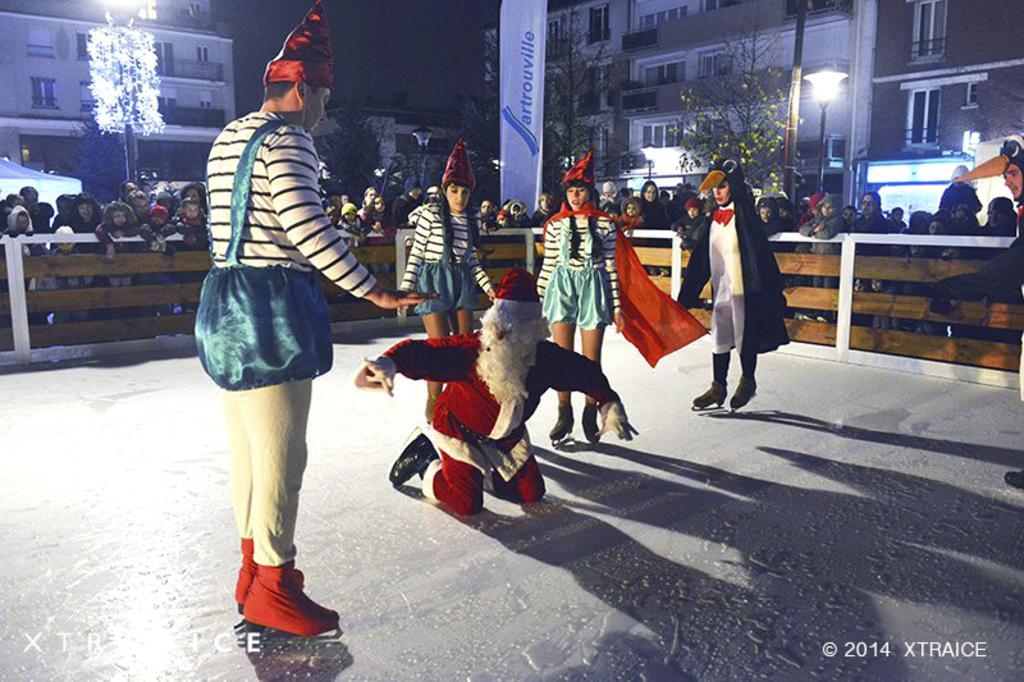Could you give a brief overview of what you see in this image? In this image I can see number of people. In the front I can see few people are wearing costumes. In the background I can see a white colour board, few trees, few lights, few buildings and on the board I can see something is written. On the bottom right side of the image I can see a watermark. 